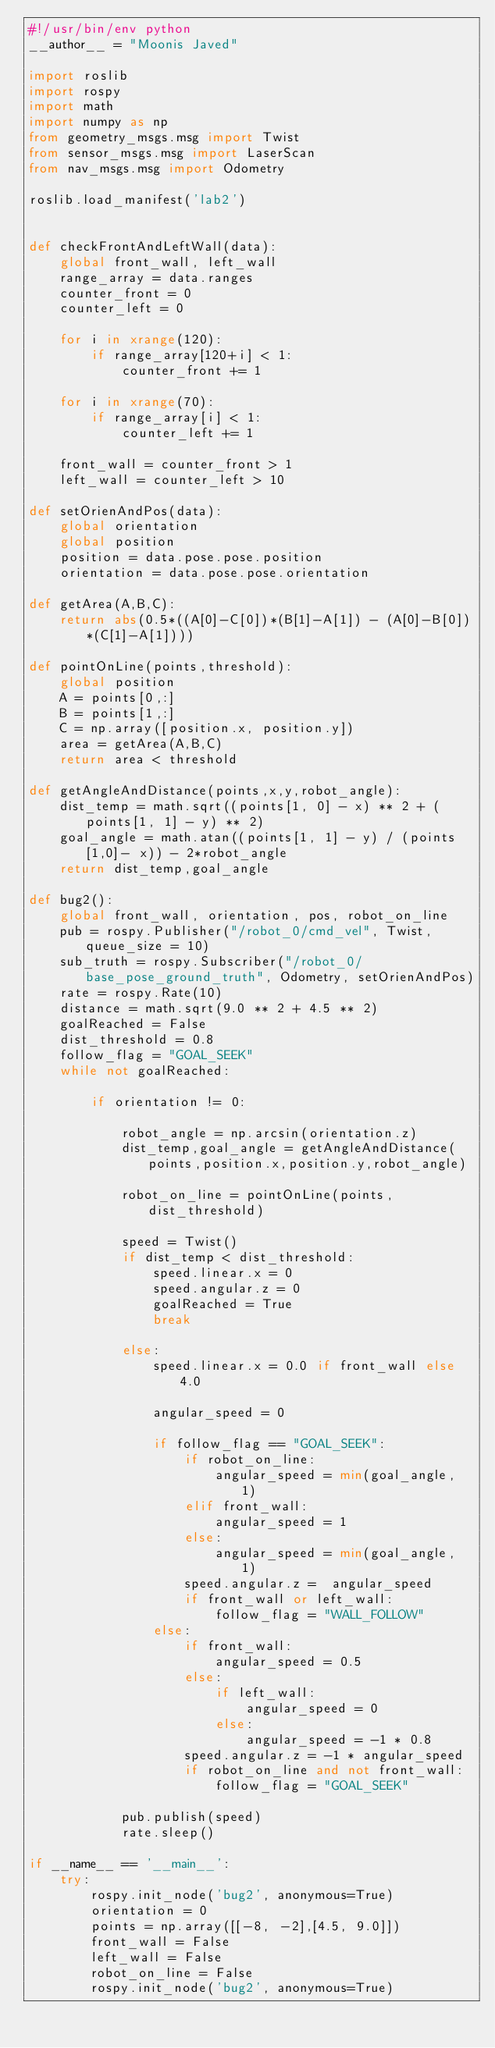<code> <loc_0><loc_0><loc_500><loc_500><_Python_>#!/usr/bin/env python
__author__ = "Moonis Javed"

import roslib
import rospy
import math
import numpy as np
from geometry_msgs.msg import Twist
from sensor_msgs.msg import LaserScan
from nav_msgs.msg import Odometry

roslib.load_manifest('lab2')


def checkFrontAndLeftWall(data):
    global front_wall, left_wall
    range_array = data.ranges
    counter_front = 0
    counter_left = 0

    for i in xrange(120):
        if range_array[120+i] < 1:
            counter_front += 1

    for i in xrange(70):
        if range_array[i] < 1:
            counter_left += 1

    front_wall = counter_front > 1
    left_wall = counter_left > 10
            
def setOrienAndPos(data):
    global orientation
    global position
    position = data.pose.pose.position
    orientation = data.pose.pose.orientation

def getArea(A,B,C):
    return abs(0.5*((A[0]-C[0])*(B[1]-A[1]) - (A[0]-B[0])*(C[1]-A[1])))

def pointOnLine(points,threshold):
    global position
    A = points[0,:]
    B = points[1,:]
    C = np.array([position.x, position.y])
    area = getArea(A,B,C)
    return area < threshold

def getAngleAndDistance(points,x,y,robot_angle):
    dist_temp = math.sqrt((points[1, 0] - x) ** 2 + (points[1, 1] - y) ** 2)
    goal_angle = math.atan((points[1, 1] - y) / (points[1,0]- x)) - 2*robot_angle
    return dist_temp,goal_angle

def bug2():
    global front_wall, orientation, pos, robot_on_line
    pub = rospy.Publisher("/robot_0/cmd_vel", Twist, queue_size = 10)
    sub_truth = rospy.Subscriber("/robot_0/base_pose_ground_truth", Odometry, setOrienAndPos)
    rate = rospy.Rate(10)
    distance = math.sqrt(9.0 ** 2 + 4.5 ** 2)
    goalReached = False
    dist_threshold = 0.8
    follow_flag = "GOAL_SEEK"
    while not goalReached:

        if orientation != 0:
            
            robot_angle = np.arcsin(orientation.z)
            dist_temp,goal_angle = getAngleAndDistance(points,position.x,position.y,robot_angle)
            
            robot_on_line = pointOnLine(points,dist_threshold)

            speed = Twist()
            if dist_temp < dist_threshold:
                speed.linear.x = 0 
                speed.angular.z = 0
                goalReached = True
                break
            
            else:
                speed.linear.x = 0.0 if front_wall else 4.0
                
                angular_speed = 0
                
                if follow_flag == "GOAL_SEEK":
                    if robot_on_line:
                        angular_speed = min(goal_angle, 1)
                    elif front_wall:
                        angular_speed = 1
                    else:
                        angular_speed = min(goal_angle, 1)
                    speed.angular.z =  angular_speed
                    if front_wall or left_wall:
                        follow_flag = "WALL_FOLLOW"
                else:
                    if front_wall:
                        angular_speed = 0.5
                    else:
                        if left_wall:
                            angular_speed = 0
                        else:
                            angular_speed = -1 * 0.8
                    speed.angular.z = -1 * angular_speed
                    if robot_on_line and not front_wall:
                        follow_flag = "GOAL_SEEK"

            pub.publish(speed)
            rate.sleep()    
          
if __name__ == '__main__':
    try:
        rospy.init_node('bug2', anonymous=True)
        orientation = 0
        points = np.array([[-8, -2],[4.5, 9.0]])
        front_wall = False
        left_wall = False
        robot_on_line = False
        rospy.init_node('bug2', anonymous=True)</code> 